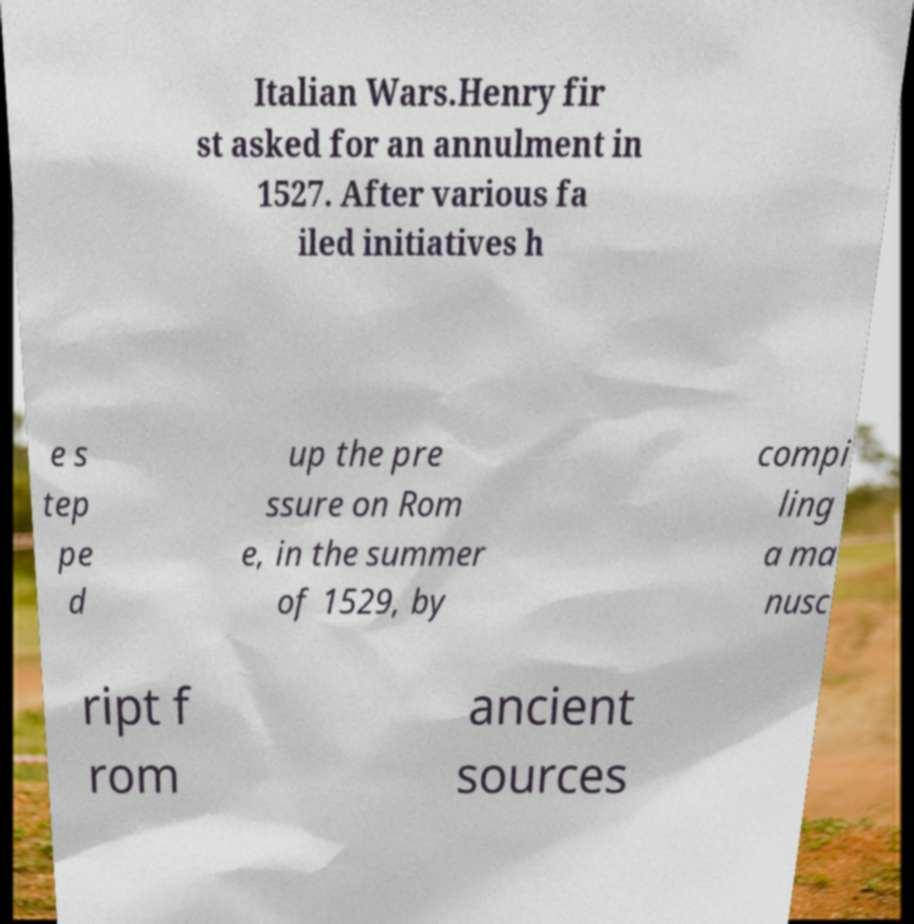Please identify and transcribe the text found in this image. Italian Wars.Henry fir st asked for an annulment in 1527. After various fa iled initiatives h e s tep pe d up the pre ssure on Rom e, in the summer of 1529, by compi ling a ma nusc ript f rom ancient sources 